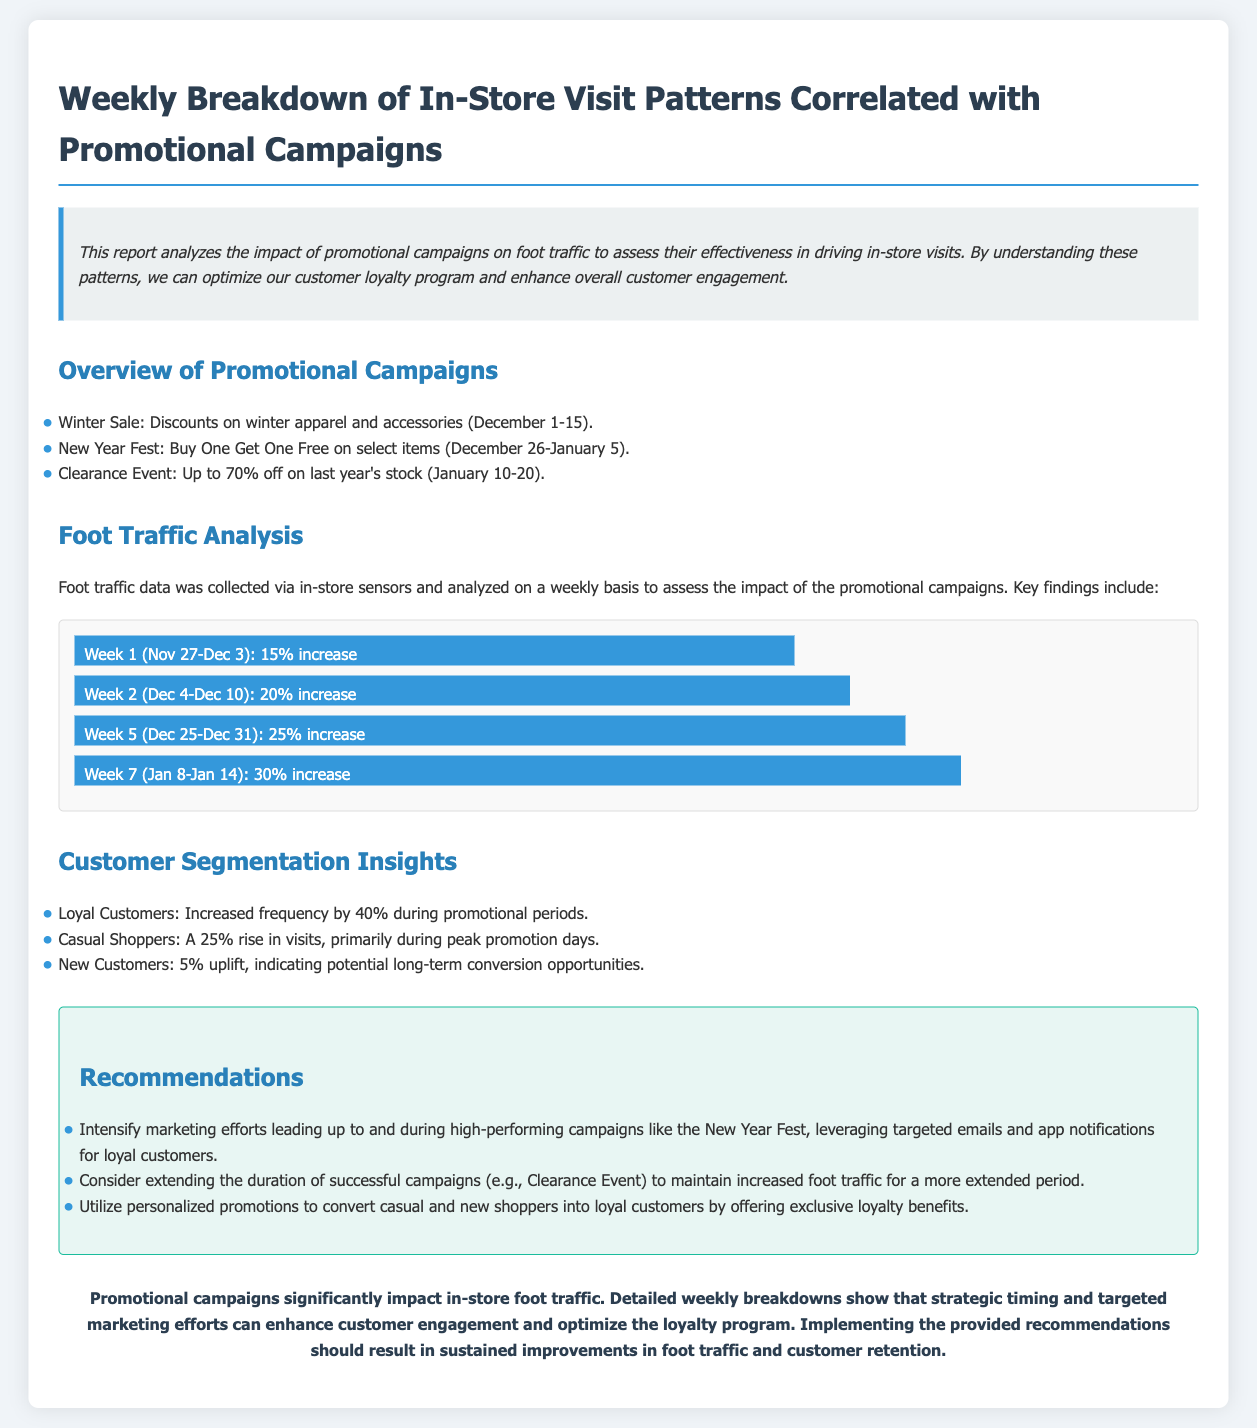What is the title of the report? The title of the report is presented at the beginning of the document.
Answer: Weekly Breakdown of In-Store Visit Patterns Correlated with Promotional Campaigns What percentage increase was observed in Week 2? The percentage increase for Week 2 is specifically stated in the foot traffic analysis section.
Answer: 20% increase Which promotional campaign offered "Buy One Get One Free"? The promotional campaign that offered this specific deal is detailed in the overview section.
Answer: New Year Fest What was the increase in visits for loyal customers during promotions? The document specifies the increase in frequency for loyal customers during promotional periods.
Answer: 40% What was the timing of the Winter Sale? The timing for the Winter Sale is provided in the overview section of the report.
Answer: December 1-15 Which week had the highest foot traffic increase? The week with the highest foot traffic increase is indicated in the foot traffic analysis section.
Answer: Week 7 (Jan 8-Jan 14) What is one of the recommendations for improving foot traffic? One of the recommendations is mentioned in the recommendations section.
Answer: Intensify marketing efforts What was the percentage increase for new customers? The document mentions the percentage increase for new customers specifically.
Answer: 5% uplift 